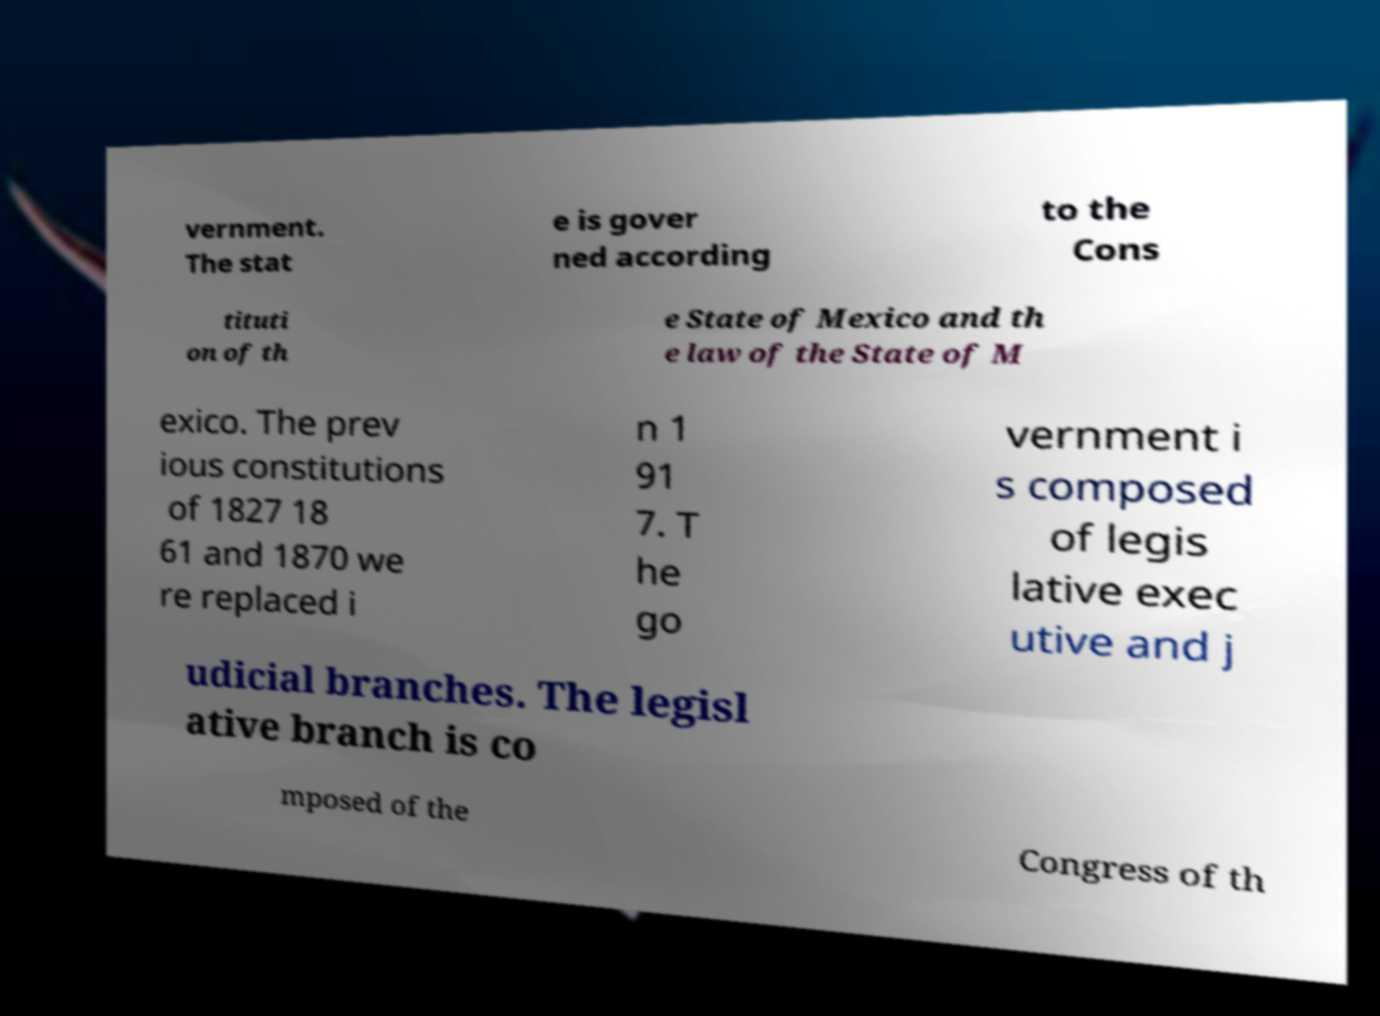For documentation purposes, I need the text within this image transcribed. Could you provide that? vernment. The stat e is gover ned according to the Cons tituti on of th e State of Mexico and th e law of the State of M exico. The prev ious constitutions of 1827 18 61 and 1870 we re replaced i n 1 91 7. T he go vernment i s composed of legis lative exec utive and j udicial branches. The legisl ative branch is co mposed of the Congress of th 